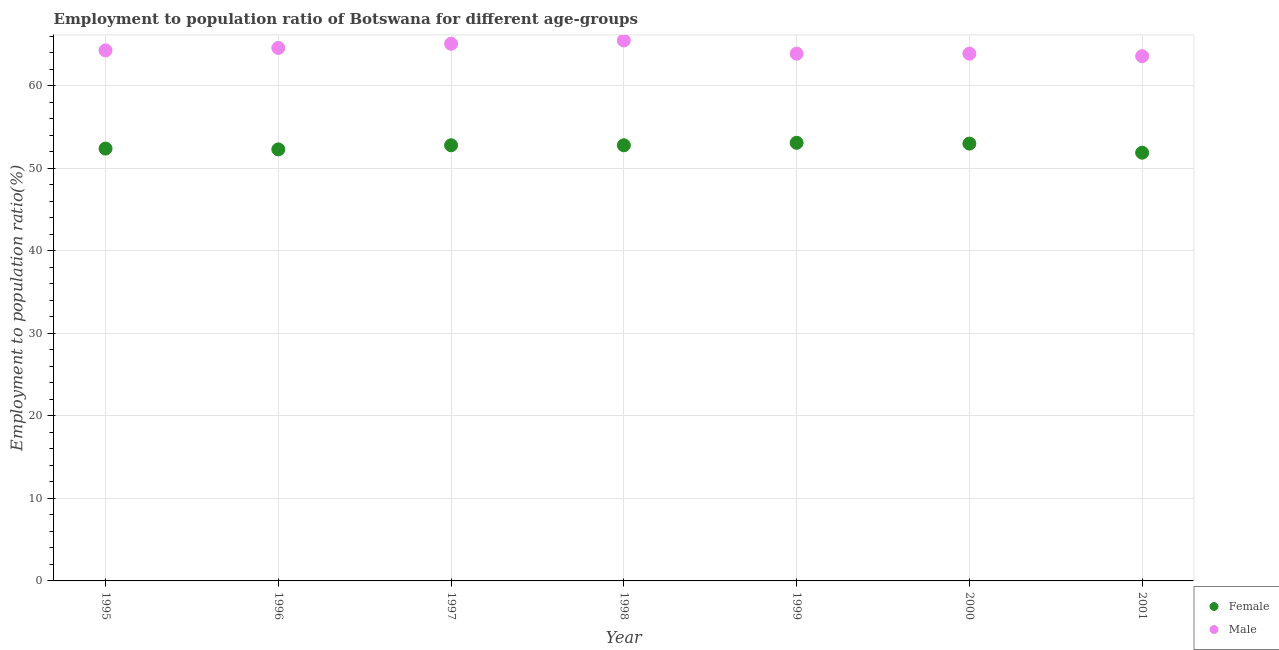Is the number of dotlines equal to the number of legend labels?
Your response must be concise. Yes. What is the employment to population ratio(male) in 1999?
Keep it short and to the point. 63.9. Across all years, what is the maximum employment to population ratio(male)?
Offer a very short reply. 65.5. Across all years, what is the minimum employment to population ratio(male)?
Ensure brevity in your answer.  63.6. In which year was the employment to population ratio(female) minimum?
Give a very brief answer. 2001. What is the total employment to population ratio(male) in the graph?
Your answer should be compact. 450.9. What is the difference between the employment to population ratio(male) in 2000 and the employment to population ratio(female) in 1996?
Your response must be concise. 11.6. What is the average employment to population ratio(female) per year?
Ensure brevity in your answer.  52.61. In the year 1995, what is the difference between the employment to population ratio(male) and employment to population ratio(female)?
Give a very brief answer. 11.9. In how many years, is the employment to population ratio(female) greater than 64 %?
Provide a short and direct response. 0. What is the ratio of the employment to population ratio(male) in 1995 to that in 1997?
Make the answer very short. 0.99. What is the difference between the highest and the second highest employment to population ratio(male)?
Give a very brief answer. 0.4. What is the difference between the highest and the lowest employment to population ratio(female)?
Make the answer very short. 1.2. In how many years, is the employment to population ratio(female) greater than the average employment to population ratio(female) taken over all years?
Your answer should be compact. 4. Is the sum of the employment to population ratio(female) in 1995 and 1996 greater than the maximum employment to population ratio(male) across all years?
Keep it short and to the point. Yes. Is the employment to population ratio(male) strictly greater than the employment to population ratio(female) over the years?
Ensure brevity in your answer.  Yes. Is the employment to population ratio(male) strictly less than the employment to population ratio(female) over the years?
Give a very brief answer. No. How many years are there in the graph?
Provide a succinct answer. 7. Does the graph contain any zero values?
Your answer should be compact. No. Does the graph contain grids?
Offer a very short reply. Yes. Where does the legend appear in the graph?
Offer a terse response. Bottom right. What is the title of the graph?
Provide a short and direct response. Employment to population ratio of Botswana for different age-groups. What is the label or title of the X-axis?
Offer a terse response. Year. What is the label or title of the Y-axis?
Offer a terse response. Employment to population ratio(%). What is the Employment to population ratio(%) in Female in 1995?
Offer a very short reply. 52.4. What is the Employment to population ratio(%) in Male in 1995?
Keep it short and to the point. 64.3. What is the Employment to population ratio(%) in Female in 1996?
Your response must be concise. 52.3. What is the Employment to population ratio(%) of Male in 1996?
Provide a succinct answer. 64.6. What is the Employment to population ratio(%) of Female in 1997?
Provide a succinct answer. 52.8. What is the Employment to population ratio(%) in Male in 1997?
Offer a terse response. 65.1. What is the Employment to population ratio(%) of Female in 1998?
Offer a very short reply. 52.8. What is the Employment to population ratio(%) of Male in 1998?
Offer a very short reply. 65.5. What is the Employment to population ratio(%) in Female in 1999?
Your answer should be very brief. 53.1. What is the Employment to population ratio(%) in Male in 1999?
Give a very brief answer. 63.9. What is the Employment to population ratio(%) in Male in 2000?
Provide a short and direct response. 63.9. What is the Employment to population ratio(%) of Female in 2001?
Provide a succinct answer. 51.9. What is the Employment to population ratio(%) in Male in 2001?
Give a very brief answer. 63.6. Across all years, what is the maximum Employment to population ratio(%) in Female?
Provide a succinct answer. 53.1. Across all years, what is the maximum Employment to population ratio(%) of Male?
Your response must be concise. 65.5. Across all years, what is the minimum Employment to population ratio(%) of Female?
Your answer should be very brief. 51.9. Across all years, what is the minimum Employment to population ratio(%) of Male?
Provide a succinct answer. 63.6. What is the total Employment to population ratio(%) in Female in the graph?
Give a very brief answer. 368.3. What is the total Employment to population ratio(%) of Male in the graph?
Provide a short and direct response. 450.9. What is the difference between the Employment to population ratio(%) in Female in 1995 and that in 1997?
Give a very brief answer. -0.4. What is the difference between the Employment to population ratio(%) of Female in 1995 and that in 1998?
Make the answer very short. -0.4. What is the difference between the Employment to population ratio(%) of Female in 1995 and that in 1999?
Your answer should be compact. -0.7. What is the difference between the Employment to population ratio(%) in Male in 1995 and that in 1999?
Provide a short and direct response. 0.4. What is the difference between the Employment to population ratio(%) in Female in 1995 and that in 2000?
Provide a short and direct response. -0.6. What is the difference between the Employment to population ratio(%) in Female in 1995 and that in 2001?
Give a very brief answer. 0.5. What is the difference between the Employment to population ratio(%) of Male in 1995 and that in 2001?
Give a very brief answer. 0.7. What is the difference between the Employment to population ratio(%) of Female in 1996 and that in 1997?
Offer a very short reply. -0.5. What is the difference between the Employment to population ratio(%) in Female in 1996 and that in 1998?
Ensure brevity in your answer.  -0.5. What is the difference between the Employment to population ratio(%) of Male in 1996 and that in 1998?
Offer a terse response. -0.9. What is the difference between the Employment to population ratio(%) of Male in 1996 and that in 1999?
Keep it short and to the point. 0.7. What is the difference between the Employment to population ratio(%) in Female in 1996 and that in 2000?
Offer a terse response. -0.7. What is the difference between the Employment to population ratio(%) of Male in 1996 and that in 2000?
Ensure brevity in your answer.  0.7. What is the difference between the Employment to population ratio(%) in Female in 1996 and that in 2001?
Offer a terse response. 0.4. What is the difference between the Employment to population ratio(%) of Male in 1997 and that in 1998?
Your answer should be very brief. -0.4. What is the difference between the Employment to population ratio(%) of Female in 1997 and that in 1999?
Give a very brief answer. -0.3. What is the difference between the Employment to population ratio(%) in Male in 1997 and that in 2000?
Offer a very short reply. 1.2. What is the difference between the Employment to population ratio(%) of Female in 1997 and that in 2001?
Keep it short and to the point. 0.9. What is the difference between the Employment to population ratio(%) in Male in 1997 and that in 2001?
Keep it short and to the point. 1.5. What is the difference between the Employment to population ratio(%) of Female in 2000 and that in 2001?
Ensure brevity in your answer.  1.1. What is the difference between the Employment to population ratio(%) in Male in 2000 and that in 2001?
Offer a very short reply. 0.3. What is the difference between the Employment to population ratio(%) in Female in 1995 and the Employment to population ratio(%) in Male in 1998?
Your answer should be very brief. -13.1. What is the difference between the Employment to population ratio(%) in Female in 1995 and the Employment to population ratio(%) in Male in 1999?
Provide a succinct answer. -11.5. What is the difference between the Employment to population ratio(%) of Female in 1995 and the Employment to population ratio(%) of Male in 2001?
Your answer should be compact. -11.2. What is the difference between the Employment to population ratio(%) in Female in 1996 and the Employment to population ratio(%) in Male in 1997?
Make the answer very short. -12.8. What is the difference between the Employment to population ratio(%) in Female in 1996 and the Employment to population ratio(%) in Male in 1998?
Provide a short and direct response. -13.2. What is the difference between the Employment to population ratio(%) of Female in 1996 and the Employment to population ratio(%) of Male in 1999?
Keep it short and to the point. -11.6. What is the difference between the Employment to population ratio(%) in Female in 1996 and the Employment to population ratio(%) in Male in 2001?
Your response must be concise. -11.3. What is the difference between the Employment to population ratio(%) in Female in 1997 and the Employment to population ratio(%) in Male in 1998?
Keep it short and to the point. -12.7. What is the difference between the Employment to population ratio(%) of Female in 1997 and the Employment to population ratio(%) of Male in 2000?
Your answer should be compact. -11.1. What is the difference between the Employment to population ratio(%) in Female in 1998 and the Employment to population ratio(%) in Male in 2000?
Your answer should be compact. -11.1. What is the difference between the Employment to population ratio(%) in Female in 1998 and the Employment to population ratio(%) in Male in 2001?
Give a very brief answer. -10.8. What is the difference between the Employment to population ratio(%) of Female in 2000 and the Employment to population ratio(%) of Male in 2001?
Give a very brief answer. -10.6. What is the average Employment to population ratio(%) of Female per year?
Provide a short and direct response. 52.61. What is the average Employment to population ratio(%) in Male per year?
Provide a short and direct response. 64.41. In the year 1995, what is the difference between the Employment to population ratio(%) of Female and Employment to population ratio(%) of Male?
Your answer should be compact. -11.9. In the year 1996, what is the difference between the Employment to population ratio(%) in Female and Employment to population ratio(%) in Male?
Your answer should be compact. -12.3. In the year 1998, what is the difference between the Employment to population ratio(%) in Female and Employment to population ratio(%) in Male?
Your answer should be very brief. -12.7. In the year 2000, what is the difference between the Employment to population ratio(%) in Female and Employment to population ratio(%) in Male?
Keep it short and to the point. -10.9. What is the ratio of the Employment to population ratio(%) in Female in 1995 to that in 1996?
Provide a short and direct response. 1. What is the ratio of the Employment to population ratio(%) of Male in 1995 to that in 1996?
Ensure brevity in your answer.  1. What is the ratio of the Employment to population ratio(%) in Female in 1995 to that in 1997?
Offer a very short reply. 0.99. What is the ratio of the Employment to population ratio(%) in Male in 1995 to that in 1997?
Give a very brief answer. 0.99. What is the ratio of the Employment to population ratio(%) of Male in 1995 to that in 1998?
Offer a terse response. 0.98. What is the ratio of the Employment to population ratio(%) in Female in 1995 to that in 1999?
Keep it short and to the point. 0.99. What is the ratio of the Employment to population ratio(%) in Male in 1995 to that in 1999?
Keep it short and to the point. 1.01. What is the ratio of the Employment to population ratio(%) in Female in 1995 to that in 2000?
Your answer should be very brief. 0.99. What is the ratio of the Employment to population ratio(%) in Female in 1995 to that in 2001?
Offer a very short reply. 1.01. What is the ratio of the Employment to population ratio(%) of Male in 1995 to that in 2001?
Offer a terse response. 1.01. What is the ratio of the Employment to population ratio(%) in Male in 1996 to that in 1997?
Offer a very short reply. 0.99. What is the ratio of the Employment to population ratio(%) of Male in 1996 to that in 1998?
Your answer should be very brief. 0.99. What is the ratio of the Employment to population ratio(%) in Female in 1996 to that in 1999?
Your response must be concise. 0.98. What is the ratio of the Employment to population ratio(%) in Male in 1996 to that in 1999?
Your answer should be compact. 1.01. What is the ratio of the Employment to population ratio(%) in Female in 1996 to that in 2000?
Give a very brief answer. 0.99. What is the ratio of the Employment to population ratio(%) in Male in 1996 to that in 2000?
Your answer should be compact. 1.01. What is the ratio of the Employment to population ratio(%) in Female in 1996 to that in 2001?
Ensure brevity in your answer.  1.01. What is the ratio of the Employment to population ratio(%) in Male in 1996 to that in 2001?
Offer a terse response. 1.02. What is the ratio of the Employment to population ratio(%) in Female in 1997 to that in 1998?
Offer a terse response. 1. What is the ratio of the Employment to population ratio(%) in Male in 1997 to that in 1999?
Your answer should be very brief. 1.02. What is the ratio of the Employment to population ratio(%) in Female in 1997 to that in 2000?
Your answer should be compact. 1. What is the ratio of the Employment to population ratio(%) in Male in 1997 to that in 2000?
Keep it short and to the point. 1.02. What is the ratio of the Employment to population ratio(%) of Female in 1997 to that in 2001?
Ensure brevity in your answer.  1.02. What is the ratio of the Employment to population ratio(%) in Male in 1997 to that in 2001?
Make the answer very short. 1.02. What is the ratio of the Employment to population ratio(%) in Female in 1998 to that in 1999?
Keep it short and to the point. 0.99. What is the ratio of the Employment to population ratio(%) in Female in 1998 to that in 2000?
Ensure brevity in your answer.  1. What is the ratio of the Employment to population ratio(%) in Male in 1998 to that in 2000?
Provide a short and direct response. 1.02. What is the ratio of the Employment to population ratio(%) of Female in 1998 to that in 2001?
Your response must be concise. 1.02. What is the ratio of the Employment to population ratio(%) of Male in 1998 to that in 2001?
Your answer should be compact. 1.03. What is the ratio of the Employment to population ratio(%) of Female in 1999 to that in 2000?
Ensure brevity in your answer.  1. What is the ratio of the Employment to population ratio(%) of Female in 1999 to that in 2001?
Your answer should be very brief. 1.02. What is the ratio of the Employment to population ratio(%) in Male in 1999 to that in 2001?
Offer a very short reply. 1. What is the ratio of the Employment to population ratio(%) of Female in 2000 to that in 2001?
Your answer should be compact. 1.02. What is the difference between the highest and the second highest Employment to population ratio(%) in Male?
Make the answer very short. 0.4. What is the difference between the highest and the lowest Employment to population ratio(%) of Male?
Your answer should be very brief. 1.9. 